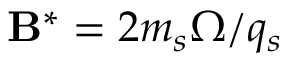Convert formula to latex. <formula><loc_0><loc_0><loc_500><loc_500>{ \mathbf B ^ { * } = 2 m _ { s } \boldsymbol \Omega / q _ { s } }</formula> 